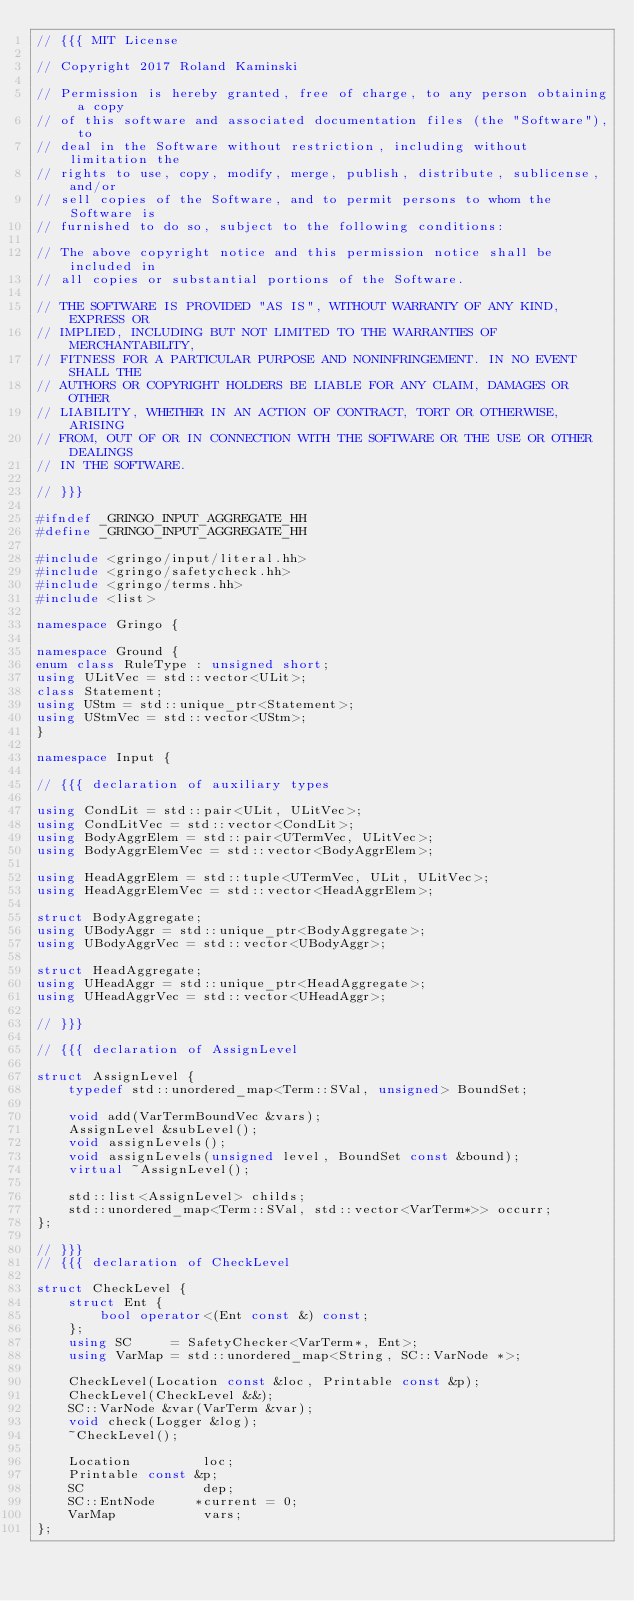<code> <loc_0><loc_0><loc_500><loc_500><_C++_>// {{{ MIT License

// Copyright 2017 Roland Kaminski

// Permission is hereby granted, free of charge, to any person obtaining a copy
// of this software and associated documentation files (the "Software"), to
// deal in the Software without restriction, including without limitation the
// rights to use, copy, modify, merge, publish, distribute, sublicense, and/or
// sell copies of the Software, and to permit persons to whom the Software is
// furnished to do so, subject to the following conditions:

// The above copyright notice and this permission notice shall be included in
// all copies or substantial portions of the Software.

// THE SOFTWARE IS PROVIDED "AS IS", WITHOUT WARRANTY OF ANY KIND, EXPRESS OR
// IMPLIED, INCLUDING BUT NOT LIMITED TO THE WARRANTIES OF MERCHANTABILITY,
// FITNESS FOR A PARTICULAR PURPOSE AND NONINFRINGEMENT. IN NO EVENT SHALL THE
// AUTHORS OR COPYRIGHT HOLDERS BE LIABLE FOR ANY CLAIM, DAMAGES OR OTHER
// LIABILITY, WHETHER IN AN ACTION OF CONTRACT, TORT OR OTHERWISE, ARISING
// FROM, OUT OF OR IN CONNECTION WITH THE SOFTWARE OR THE USE OR OTHER DEALINGS
// IN THE SOFTWARE.

// }}}

#ifndef _GRINGO_INPUT_AGGREGATE_HH
#define _GRINGO_INPUT_AGGREGATE_HH

#include <gringo/input/literal.hh>
#include <gringo/safetycheck.hh>
#include <gringo/terms.hh>
#include <list>

namespace Gringo {

namespace Ground {
enum class RuleType : unsigned short;
using ULitVec = std::vector<ULit>;
class Statement;
using UStm = std::unique_ptr<Statement>;
using UStmVec = std::vector<UStm>;
}

namespace Input {

// {{{ declaration of auxiliary types

using CondLit = std::pair<ULit, ULitVec>;
using CondLitVec = std::vector<CondLit>;
using BodyAggrElem = std::pair<UTermVec, ULitVec>;
using BodyAggrElemVec = std::vector<BodyAggrElem>;

using HeadAggrElem = std::tuple<UTermVec, ULit, ULitVec>;
using HeadAggrElemVec = std::vector<HeadAggrElem>;

struct BodyAggregate;
using UBodyAggr = std::unique_ptr<BodyAggregate>;
using UBodyAggrVec = std::vector<UBodyAggr>;

struct HeadAggregate;
using UHeadAggr = std::unique_ptr<HeadAggregate>;
using UHeadAggrVec = std::vector<UHeadAggr>;

// }}}

// {{{ declaration of AssignLevel

struct AssignLevel {
    typedef std::unordered_map<Term::SVal, unsigned> BoundSet;

    void add(VarTermBoundVec &vars);
    AssignLevel &subLevel();
    void assignLevels();
    void assignLevels(unsigned level, BoundSet const &bound);
    virtual ~AssignLevel();

    std::list<AssignLevel> childs;
    std::unordered_map<Term::SVal, std::vector<VarTerm*>> occurr;
};

// }}}
// {{{ declaration of CheckLevel

struct CheckLevel {
    struct Ent {
        bool operator<(Ent const &) const;
    };
    using SC     = SafetyChecker<VarTerm*, Ent>;
    using VarMap = std::unordered_map<String, SC::VarNode *>;

    CheckLevel(Location const &loc, Printable const &p);
    CheckLevel(CheckLevel &&);
    SC::VarNode &var(VarTerm &var);
    void check(Logger &log);
    ~CheckLevel();

    Location         loc;
    Printable const &p;
    SC               dep;
    SC::EntNode     *current = 0;
    VarMap           vars;
};</code> 